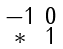<formula> <loc_0><loc_0><loc_500><loc_500>\begin{smallmatrix} - 1 & 0 \\ * & 1 \end{smallmatrix}</formula> 